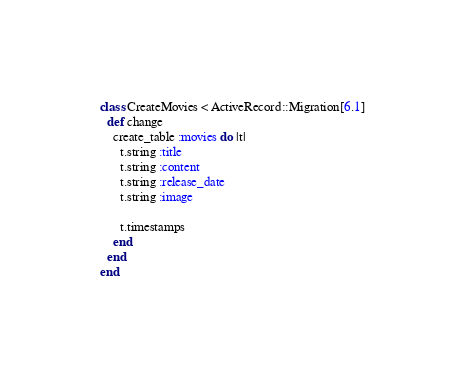Convert code to text. <code><loc_0><loc_0><loc_500><loc_500><_Ruby_>class CreateMovies < ActiveRecord::Migration[6.1]
  def change
    create_table :movies do |t|
      t.string :title
      t.string :content
      t.string :release_date
      t.string :image

      t.timestamps
    end
  end
end
</code> 